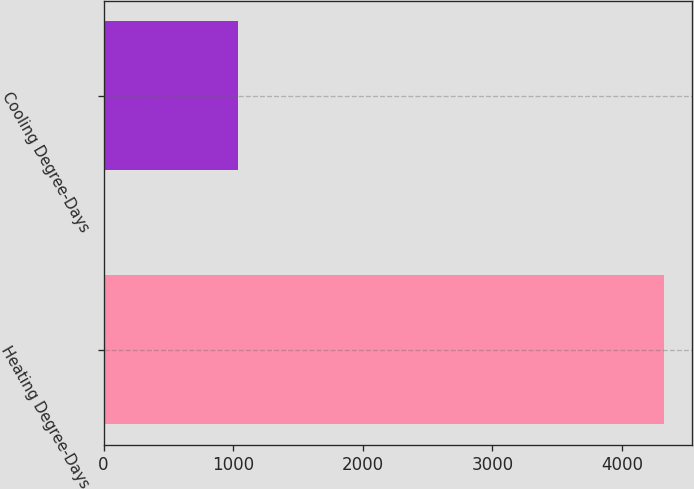Convert chart to OTSL. <chart><loc_0><loc_0><loc_500><loc_500><bar_chart><fcel>Heating Degree-Days<fcel>Cooling Degree-Days<nl><fcel>4326<fcel>1035<nl></chart> 